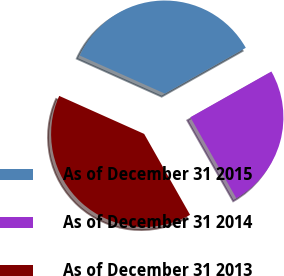Convert chart. <chart><loc_0><loc_0><loc_500><loc_500><pie_chart><fcel>As of December 31 2015<fcel>As of December 31 2014<fcel>As of December 31 2013<nl><fcel>35.12%<fcel>24.97%<fcel>39.91%<nl></chart> 